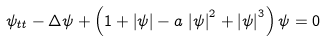<formula> <loc_0><loc_0><loc_500><loc_500>\psi _ { t t } - \Delta \psi + \left ( 1 + \left | \psi \right | - a \, \left | \psi \right | ^ { 2 } + \left | \psi \right | ^ { 3 } \right ) \psi = 0</formula> 